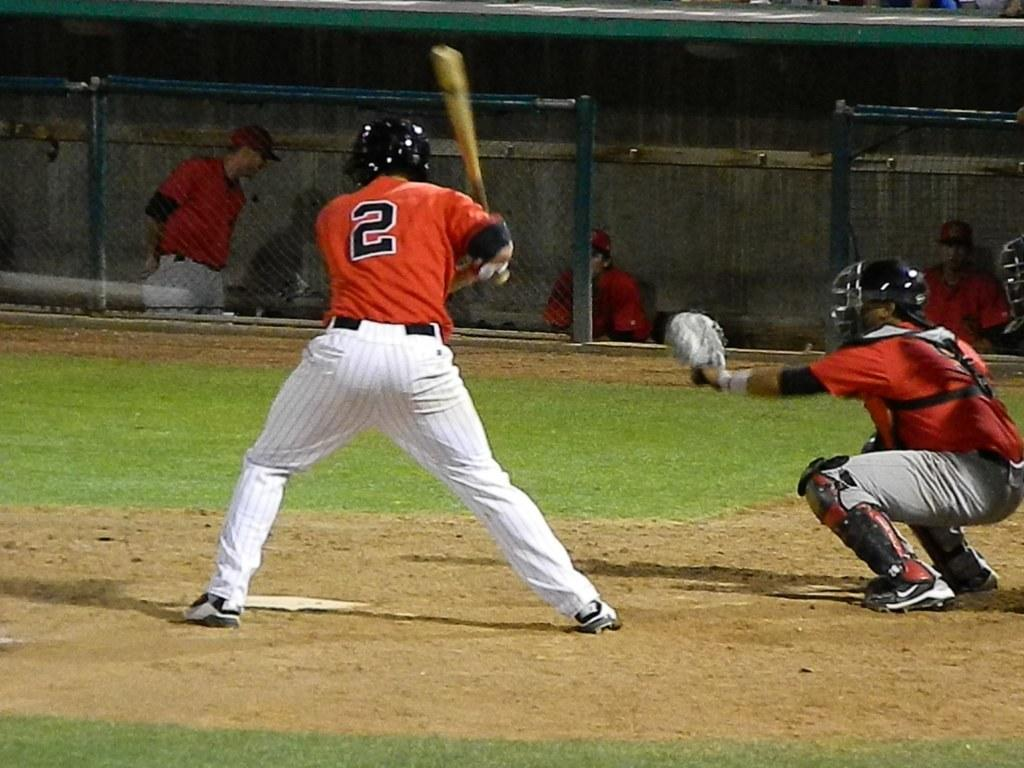<image>
Provide a brief description of the given image. Baseball player in front of catcher with a black number 2 on his jersey. 